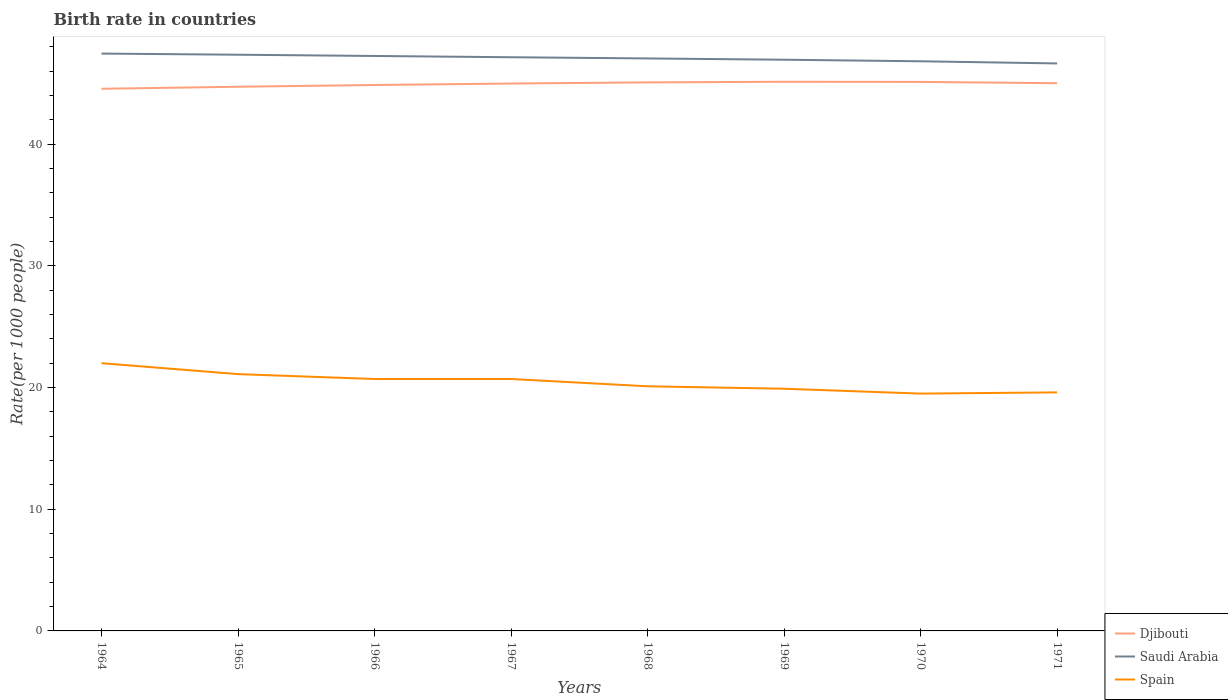How many different coloured lines are there?
Your response must be concise. 3. Does the line corresponding to Djibouti intersect with the line corresponding to Saudi Arabia?
Provide a succinct answer. No. Across all years, what is the maximum birth rate in Saudi Arabia?
Offer a terse response. 46.63. In which year was the birth rate in Djibouti maximum?
Keep it short and to the point. 1964. What is the total birth rate in Spain in the graph?
Ensure brevity in your answer.  1.2. What is the difference between the highest and the second highest birth rate in Saudi Arabia?
Provide a short and direct response. 0.81. What is the difference between the highest and the lowest birth rate in Djibouti?
Keep it short and to the point. 5. Is the birth rate in Djibouti strictly greater than the birth rate in Spain over the years?
Give a very brief answer. No. How many lines are there?
Your response must be concise. 3. How many years are there in the graph?
Offer a very short reply. 8. Are the values on the major ticks of Y-axis written in scientific E-notation?
Your answer should be very brief. No. Does the graph contain any zero values?
Give a very brief answer. No. Where does the legend appear in the graph?
Your answer should be very brief. Bottom right. How many legend labels are there?
Offer a terse response. 3. How are the legend labels stacked?
Provide a short and direct response. Vertical. What is the title of the graph?
Your answer should be compact. Birth rate in countries. What is the label or title of the Y-axis?
Your response must be concise. Rate(per 1000 people). What is the Rate(per 1000 people) in Djibouti in 1964?
Your answer should be compact. 44.55. What is the Rate(per 1000 people) of Saudi Arabia in 1964?
Your answer should be very brief. 47.44. What is the Rate(per 1000 people) of Spain in 1964?
Ensure brevity in your answer.  22. What is the Rate(per 1000 people) of Djibouti in 1965?
Your answer should be compact. 44.71. What is the Rate(per 1000 people) of Saudi Arabia in 1965?
Offer a very short reply. 47.34. What is the Rate(per 1000 people) of Spain in 1965?
Give a very brief answer. 21.1. What is the Rate(per 1000 people) of Djibouti in 1966?
Keep it short and to the point. 44.86. What is the Rate(per 1000 people) in Saudi Arabia in 1966?
Provide a succinct answer. 47.24. What is the Rate(per 1000 people) of Spain in 1966?
Offer a very short reply. 20.7. What is the Rate(per 1000 people) in Djibouti in 1967?
Give a very brief answer. 44.98. What is the Rate(per 1000 people) of Saudi Arabia in 1967?
Make the answer very short. 47.14. What is the Rate(per 1000 people) of Spain in 1967?
Your answer should be compact. 20.7. What is the Rate(per 1000 people) in Djibouti in 1968?
Your answer should be very brief. 45.07. What is the Rate(per 1000 people) in Saudi Arabia in 1968?
Your answer should be compact. 47.04. What is the Rate(per 1000 people) of Spain in 1968?
Offer a terse response. 20.1. What is the Rate(per 1000 people) in Djibouti in 1969?
Make the answer very short. 45.12. What is the Rate(per 1000 people) in Saudi Arabia in 1969?
Provide a succinct answer. 46.93. What is the Rate(per 1000 people) in Spain in 1969?
Your response must be concise. 19.9. What is the Rate(per 1000 people) of Djibouti in 1970?
Provide a short and direct response. 45.11. What is the Rate(per 1000 people) of Saudi Arabia in 1970?
Give a very brief answer. 46.81. What is the Rate(per 1000 people) in Djibouti in 1971?
Provide a succinct answer. 45. What is the Rate(per 1000 people) of Saudi Arabia in 1971?
Provide a succinct answer. 46.63. What is the Rate(per 1000 people) in Spain in 1971?
Offer a very short reply. 19.6. Across all years, what is the maximum Rate(per 1000 people) in Djibouti?
Provide a succinct answer. 45.12. Across all years, what is the maximum Rate(per 1000 people) of Saudi Arabia?
Give a very brief answer. 47.44. Across all years, what is the minimum Rate(per 1000 people) in Djibouti?
Provide a short and direct response. 44.55. Across all years, what is the minimum Rate(per 1000 people) of Saudi Arabia?
Ensure brevity in your answer.  46.63. What is the total Rate(per 1000 people) in Djibouti in the graph?
Ensure brevity in your answer.  359.4. What is the total Rate(per 1000 people) in Saudi Arabia in the graph?
Provide a succinct answer. 376.57. What is the total Rate(per 1000 people) of Spain in the graph?
Offer a terse response. 163.6. What is the difference between the Rate(per 1000 people) in Djibouti in 1964 and that in 1965?
Offer a terse response. -0.17. What is the difference between the Rate(per 1000 people) of Saudi Arabia in 1964 and that in 1965?
Offer a very short reply. 0.09. What is the difference between the Rate(per 1000 people) in Djibouti in 1964 and that in 1966?
Offer a very short reply. -0.31. What is the difference between the Rate(per 1000 people) of Saudi Arabia in 1964 and that in 1966?
Ensure brevity in your answer.  0.2. What is the difference between the Rate(per 1000 people) of Djibouti in 1964 and that in 1967?
Your response must be concise. -0.43. What is the difference between the Rate(per 1000 people) in Spain in 1964 and that in 1967?
Give a very brief answer. 1.3. What is the difference between the Rate(per 1000 people) of Djibouti in 1964 and that in 1968?
Offer a very short reply. -0.53. What is the difference between the Rate(per 1000 people) in Djibouti in 1964 and that in 1969?
Keep it short and to the point. -0.58. What is the difference between the Rate(per 1000 people) in Saudi Arabia in 1964 and that in 1969?
Give a very brief answer. 0.51. What is the difference between the Rate(per 1000 people) of Spain in 1964 and that in 1969?
Your answer should be very brief. 2.1. What is the difference between the Rate(per 1000 people) in Djibouti in 1964 and that in 1970?
Provide a short and direct response. -0.56. What is the difference between the Rate(per 1000 people) of Saudi Arabia in 1964 and that in 1970?
Make the answer very short. 0.63. What is the difference between the Rate(per 1000 people) of Djibouti in 1964 and that in 1971?
Your response must be concise. -0.46. What is the difference between the Rate(per 1000 people) in Saudi Arabia in 1964 and that in 1971?
Ensure brevity in your answer.  0.81. What is the difference between the Rate(per 1000 people) in Spain in 1964 and that in 1971?
Make the answer very short. 2.4. What is the difference between the Rate(per 1000 people) in Djibouti in 1965 and that in 1966?
Your response must be concise. -0.14. What is the difference between the Rate(per 1000 people) in Saudi Arabia in 1965 and that in 1966?
Ensure brevity in your answer.  0.1. What is the difference between the Rate(per 1000 people) of Spain in 1965 and that in 1966?
Keep it short and to the point. 0.4. What is the difference between the Rate(per 1000 people) in Djibouti in 1965 and that in 1967?
Provide a short and direct response. -0.27. What is the difference between the Rate(per 1000 people) of Saudi Arabia in 1965 and that in 1967?
Your response must be concise. 0.21. What is the difference between the Rate(per 1000 people) of Djibouti in 1965 and that in 1968?
Provide a short and direct response. -0.36. What is the difference between the Rate(per 1000 people) in Saudi Arabia in 1965 and that in 1968?
Your answer should be very brief. 0.31. What is the difference between the Rate(per 1000 people) in Djibouti in 1965 and that in 1969?
Your response must be concise. -0.41. What is the difference between the Rate(per 1000 people) of Saudi Arabia in 1965 and that in 1969?
Your answer should be compact. 0.41. What is the difference between the Rate(per 1000 people) of Djibouti in 1965 and that in 1970?
Give a very brief answer. -0.4. What is the difference between the Rate(per 1000 people) in Saudi Arabia in 1965 and that in 1970?
Make the answer very short. 0.54. What is the difference between the Rate(per 1000 people) in Djibouti in 1965 and that in 1971?
Your answer should be compact. -0.29. What is the difference between the Rate(per 1000 people) of Saudi Arabia in 1965 and that in 1971?
Offer a terse response. 0.72. What is the difference between the Rate(per 1000 people) in Djibouti in 1966 and that in 1967?
Give a very brief answer. -0.12. What is the difference between the Rate(per 1000 people) in Saudi Arabia in 1966 and that in 1967?
Make the answer very short. 0.1. What is the difference between the Rate(per 1000 people) in Spain in 1966 and that in 1967?
Your answer should be very brief. 0. What is the difference between the Rate(per 1000 people) of Djibouti in 1966 and that in 1968?
Give a very brief answer. -0.21. What is the difference between the Rate(per 1000 people) in Saudi Arabia in 1966 and that in 1968?
Offer a terse response. 0.2. What is the difference between the Rate(per 1000 people) of Djibouti in 1966 and that in 1969?
Your response must be concise. -0.27. What is the difference between the Rate(per 1000 people) of Saudi Arabia in 1966 and that in 1969?
Keep it short and to the point. 0.31. What is the difference between the Rate(per 1000 people) of Spain in 1966 and that in 1969?
Ensure brevity in your answer.  0.8. What is the difference between the Rate(per 1000 people) in Djibouti in 1966 and that in 1970?
Ensure brevity in your answer.  -0.25. What is the difference between the Rate(per 1000 people) of Saudi Arabia in 1966 and that in 1970?
Your response must be concise. 0.44. What is the difference between the Rate(per 1000 people) of Djibouti in 1966 and that in 1971?
Give a very brief answer. -0.15. What is the difference between the Rate(per 1000 people) in Saudi Arabia in 1966 and that in 1971?
Keep it short and to the point. 0.61. What is the difference between the Rate(per 1000 people) in Djibouti in 1967 and that in 1968?
Offer a terse response. -0.09. What is the difference between the Rate(per 1000 people) in Saudi Arabia in 1967 and that in 1968?
Provide a succinct answer. 0.1. What is the difference between the Rate(per 1000 people) in Spain in 1967 and that in 1968?
Ensure brevity in your answer.  0.6. What is the difference between the Rate(per 1000 people) of Djibouti in 1967 and that in 1969?
Your answer should be very brief. -0.14. What is the difference between the Rate(per 1000 people) of Saudi Arabia in 1967 and that in 1969?
Make the answer very short. 0.2. What is the difference between the Rate(per 1000 people) in Spain in 1967 and that in 1969?
Keep it short and to the point. 0.8. What is the difference between the Rate(per 1000 people) in Djibouti in 1967 and that in 1970?
Keep it short and to the point. -0.13. What is the difference between the Rate(per 1000 people) of Saudi Arabia in 1967 and that in 1970?
Your response must be concise. 0.33. What is the difference between the Rate(per 1000 people) in Spain in 1967 and that in 1970?
Your answer should be very brief. 1.2. What is the difference between the Rate(per 1000 people) in Djibouti in 1967 and that in 1971?
Your answer should be compact. -0.03. What is the difference between the Rate(per 1000 people) in Saudi Arabia in 1967 and that in 1971?
Provide a succinct answer. 0.51. What is the difference between the Rate(per 1000 people) of Spain in 1967 and that in 1971?
Make the answer very short. 1.1. What is the difference between the Rate(per 1000 people) of Djibouti in 1968 and that in 1969?
Keep it short and to the point. -0.05. What is the difference between the Rate(per 1000 people) of Saudi Arabia in 1968 and that in 1969?
Your response must be concise. 0.1. What is the difference between the Rate(per 1000 people) of Djibouti in 1968 and that in 1970?
Provide a short and direct response. -0.04. What is the difference between the Rate(per 1000 people) of Saudi Arabia in 1968 and that in 1970?
Give a very brief answer. 0.23. What is the difference between the Rate(per 1000 people) of Djibouti in 1968 and that in 1971?
Provide a short and direct response. 0.07. What is the difference between the Rate(per 1000 people) of Saudi Arabia in 1968 and that in 1971?
Keep it short and to the point. 0.41. What is the difference between the Rate(per 1000 people) in Spain in 1968 and that in 1971?
Your answer should be very brief. 0.5. What is the difference between the Rate(per 1000 people) in Djibouti in 1969 and that in 1970?
Offer a very short reply. 0.01. What is the difference between the Rate(per 1000 people) of Saudi Arabia in 1969 and that in 1970?
Give a very brief answer. 0.13. What is the difference between the Rate(per 1000 people) of Spain in 1969 and that in 1970?
Ensure brevity in your answer.  0.4. What is the difference between the Rate(per 1000 people) in Djibouti in 1969 and that in 1971?
Provide a succinct answer. 0.12. What is the difference between the Rate(per 1000 people) of Saudi Arabia in 1969 and that in 1971?
Keep it short and to the point. 0.3. What is the difference between the Rate(per 1000 people) in Djibouti in 1970 and that in 1971?
Offer a very short reply. 0.11. What is the difference between the Rate(per 1000 people) in Saudi Arabia in 1970 and that in 1971?
Make the answer very short. 0.18. What is the difference between the Rate(per 1000 people) of Djibouti in 1964 and the Rate(per 1000 people) of Saudi Arabia in 1965?
Your answer should be very brief. -2.8. What is the difference between the Rate(per 1000 people) in Djibouti in 1964 and the Rate(per 1000 people) in Spain in 1965?
Your response must be concise. 23.45. What is the difference between the Rate(per 1000 people) in Saudi Arabia in 1964 and the Rate(per 1000 people) in Spain in 1965?
Keep it short and to the point. 26.34. What is the difference between the Rate(per 1000 people) of Djibouti in 1964 and the Rate(per 1000 people) of Saudi Arabia in 1966?
Keep it short and to the point. -2.7. What is the difference between the Rate(per 1000 people) in Djibouti in 1964 and the Rate(per 1000 people) in Spain in 1966?
Make the answer very short. 23.85. What is the difference between the Rate(per 1000 people) of Saudi Arabia in 1964 and the Rate(per 1000 people) of Spain in 1966?
Your answer should be compact. 26.74. What is the difference between the Rate(per 1000 people) of Djibouti in 1964 and the Rate(per 1000 people) of Saudi Arabia in 1967?
Offer a very short reply. -2.59. What is the difference between the Rate(per 1000 people) in Djibouti in 1964 and the Rate(per 1000 people) in Spain in 1967?
Keep it short and to the point. 23.85. What is the difference between the Rate(per 1000 people) of Saudi Arabia in 1964 and the Rate(per 1000 people) of Spain in 1967?
Give a very brief answer. 26.74. What is the difference between the Rate(per 1000 people) of Djibouti in 1964 and the Rate(per 1000 people) of Saudi Arabia in 1968?
Offer a terse response. -2.49. What is the difference between the Rate(per 1000 people) of Djibouti in 1964 and the Rate(per 1000 people) of Spain in 1968?
Your answer should be compact. 24.45. What is the difference between the Rate(per 1000 people) in Saudi Arabia in 1964 and the Rate(per 1000 people) in Spain in 1968?
Provide a succinct answer. 27.34. What is the difference between the Rate(per 1000 people) of Djibouti in 1964 and the Rate(per 1000 people) of Saudi Arabia in 1969?
Your answer should be compact. -2.39. What is the difference between the Rate(per 1000 people) of Djibouti in 1964 and the Rate(per 1000 people) of Spain in 1969?
Keep it short and to the point. 24.65. What is the difference between the Rate(per 1000 people) in Saudi Arabia in 1964 and the Rate(per 1000 people) in Spain in 1969?
Offer a very short reply. 27.54. What is the difference between the Rate(per 1000 people) in Djibouti in 1964 and the Rate(per 1000 people) in Saudi Arabia in 1970?
Your answer should be very brief. -2.26. What is the difference between the Rate(per 1000 people) of Djibouti in 1964 and the Rate(per 1000 people) of Spain in 1970?
Your response must be concise. 25.05. What is the difference between the Rate(per 1000 people) in Saudi Arabia in 1964 and the Rate(per 1000 people) in Spain in 1970?
Provide a short and direct response. 27.94. What is the difference between the Rate(per 1000 people) of Djibouti in 1964 and the Rate(per 1000 people) of Saudi Arabia in 1971?
Make the answer very short. -2.08. What is the difference between the Rate(per 1000 people) in Djibouti in 1964 and the Rate(per 1000 people) in Spain in 1971?
Provide a short and direct response. 24.95. What is the difference between the Rate(per 1000 people) of Saudi Arabia in 1964 and the Rate(per 1000 people) of Spain in 1971?
Your answer should be compact. 27.84. What is the difference between the Rate(per 1000 people) of Djibouti in 1965 and the Rate(per 1000 people) of Saudi Arabia in 1966?
Provide a short and direct response. -2.53. What is the difference between the Rate(per 1000 people) of Djibouti in 1965 and the Rate(per 1000 people) of Spain in 1966?
Your answer should be very brief. 24.01. What is the difference between the Rate(per 1000 people) in Saudi Arabia in 1965 and the Rate(per 1000 people) in Spain in 1966?
Keep it short and to the point. 26.64. What is the difference between the Rate(per 1000 people) of Djibouti in 1965 and the Rate(per 1000 people) of Saudi Arabia in 1967?
Provide a short and direct response. -2.43. What is the difference between the Rate(per 1000 people) of Djibouti in 1965 and the Rate(per 1000 people) of Spain in 1967?
Offer a very short reply. 24.01. What is the difference between the Rate(per 1000 people) of Saudi Arabia in 1965 and the Rate(per 1000 people) of Spain in 1967?
Your answer should be compact. 26.64. What is the difference between the Rate(per 1000 people) in Djibouti in 1965 and the Rate(per 1000 people) in Saudi Arabia in 1968?
Provide a succinct answer. -2.33. What is the difference between the Rate(per 1000 people) in Djibouti in 1965 and the Rate(per 1000 people) in Spain in 1968?
Give a very brief answer. 24.61. What is the difference between the Rate(per 1000 people) of Saudi Arabia in 1965 and the Rate(per 1000 people) of Spain in 1968?
Provide a short and direct response. 27.25. What is the difference between the Rate(per 1000 people) of Djibouti in 1965 and the Rate(per 1000 people) of Saudi Arabia in 1969?
Provide a succinct answer. -2.22. What is the difference between the Rate(per 1000 people) of Djibouti in 1965 and the Rate(per 1000 people) of Spain in 1969?
Provide a short and direct response. 24.81. What is the difference between the Rate(per 1000 people) of Saudi Arabia in 1965 and the Rate(per 1000 people) of Spain in 1969?
Ensure brevity in your answer.  27.45. What is the difference between the Rate(per 1000 people) of Djibouti in 1965 and the Rate(per 1000 people) of Saudi Arabia in 1970?
Ensure brevity in your answer.  -2.09. What is the difference between the Rate(per 1000 people) in Djibouti in 1965 and the Rate(per 1000 people) in Spain in 1970?
Your response must be concise. 25.21. What is the difference between the Rate(per 1000 people) in Saudi Arabia in 1965 and the Rate(per 1000 people) in Spain in 1970?
Make the answer very short. 27.84. What is the difference between the Rate(per 1000 people) in Djibouti in 1965 and the Rate(per 1000 people) in Saudi Arabia in 1971?
Offer a very short reply. -1.92. What is the difference between the Rate(per 1000 people) in Djibouti in 1965 and the Rate(per 1000 people) in Spain in 1971?
Your answer should be compact. 25.11. What is the difference between the Rate(per 1000 people) of Saudi Arabia in 1965 and the Rate(per 1000 people) of Spain in 1971?
Your answer should be very brief. 27.75. What is the difference between the Rate(per 1000 people) of Djibouti in 1966 and the Rate(per 1000 people) of Saudi Arabia in 1967?
Your answer should be very brief. -2.28. What is the difference between the Rate(per 1000 people) in Djibouti in 1966 and the Rate(per 1000 people) in Spain in 1967?
Your response must be concise. 24.16. What is the difference between the Rate(per 1000 people) of Saudi Arabia in 1966 and the Rate(per 1000 people) of Spain in 1967?
Your answer should be compact. 26.54. What is the difference between the Rate(per 1000 people) of Djibouti in 1966 and the Rate(per 1000 people) of Saudi Arabia in 1968?
Your answer should be compact. -2.18. What is the difference between the Rate(per 1000 people) of Djibouti in 1966 and the Rate(per 1000 people) of Spain in 1968?
Give a very brief answer. 24.76. What is the difference between the Rate(per 1000 people) in Saudi Arabia in 1966 and the Rate(per 1000 people) in Spain in 1968?
Ensure brevity in your answer.  27.14. What is the difference between the Rate(per 1000 people) in Djibouti in 1966 and the Rate(per 1000 people) in Saudi Arabia in 1969?
Make the answer very short. -2.08. What is the difference between the Rate(per 1000 people) of Djibouti in 1966 and the Rate(per 1000 people) of Spain in 1969?
Ensure brevity in your answer.  24.96. What is the difference between the Rate(per 1000 people) in Saudi Arabia in 1966 and the Rate(per 1000 people) in Spain in 1969?
Your response must be concise. 27.34. What is the difference between the Rate(per 1000 people) of Djibouti in 1966 and the Rate(per 1000 people) of Saudi Arabia in 1970?
Ensure brevity in your answer.  -1.95. What is the difference between the Rate(per 1000 people) of Djibouti in 1966 and the Rate(per 1000 people) of Spain in 1970?
Offer a terse response. 25.36. What is the difference between the Rate(per 1000 people) of Saudi Arabia in 1966 and the Rate(per 1000 people) of Spain in 1970?
Your response must be concise. 27.74. What is the difference between the Rate(per 1000 people) of Djibouti in 1966 and the Rate(per 1000 people) of Saudi Arabia in 1971?
Your answer should be compact. -1.77. What is the difference between the Rate(per 1000 people) of Djibouti in 1966 and the Rate(per 1000 people) of Spain in 1971?
Provide a succinct answer. 25.26. What is the difference between the Rate(per 1000 people) of Saudi Arabia in 1966 and the Rate(per 1000 people) of Spain in 1971?
Offer a terse response. 27.64. What is the difference between the Rate(per 1000 people) of Djibouti in 1967 and the Rate(per 1000 people) of Saudi Arabia in 1968?
Keep it short and to the point. -2.06. What is the difference between the Rate(per 1000 people) in Djibouti in 1967 and the Rate(per 1000 people) in Spain in 1968?
Provide a succinct answer. 24.88. What is the difference between the Rate(per 1000 people) of Saudi Arabia in 1967 and the Rate(per 1000 people) of Spain in 1968?
Give a very brief answer. 27.04. What is the difference between the Rate(per 1000 people) in Djibouti in 1967 and the Rate(per 1000 people) in Saudi Arabia in 1969?
Keep it short and to the point. -1.96. What is the difference between the Rate(per 1000 people) in Djibouti in 1967 and the Rate(per 1000 people) in Spain in 1969?
Provide a succinct answer. 25.08. What is the difference between the Rate(per 1000 people) of Saudi Arabia in 1967 and the Rate(per 1000 people) of Spain in 1969?
Provide a short and direct response. 27.24. What is the difference between the Rate(per 1000 people) of Djibouti in 1967 and the Rate(per 1000 people) of Saudi Arabia in 1970?
Your answer should be compact. -1.83. What is the difference between the Rate(per 1000 people) of Djibouti in 1967 and the Rate(per 1000 people) of Spain in 1970?
Provide a short and direct response. 25.48. What is the difference between the Rate(per 1000 people) of Saudi Arabia in 1967 and the Rate(per 1000 people) of Spain in 1970?
Provide a succinct answer. 27.64. What is the difference between the Rate(per 1000 people) of Djibouti in 1967 and the Rate(per 1000 people) of Saudi Arabia in 1971?
Ensure brevity in your answer.  -1.65. What is the difference between the Rate(per 1000 people) of Djibouti in 1967 and the Rate(per 1000 people) of Spain in 1971?
Your response must be concise. 25.38. What is the difference between the Rate(per 1000 people) of Saudi Arabia in 1967 and the Rate(per 1000 people) of Spain in 1971?
Provide a short and direct response. 27.54. What is the difference between the Rate(per 1000 people) of Djibouti in 1968 and the Rate(per 1000 people) of Saudi Arabia in 1969?
Make the answer very short. -1.86. What is the difference between the Rate(per 1000 people) of Djibouti in 1968 and the Rate(per 1000 people) of Spain in 1969?
Offer a terse response. 25.17. What is the difference between the Rate(per 1000 people) of Saudi Arabia in 1968 and the Rate(per 1000 people) of Spain in 1969?
Your answer should be very brief. 27.14. What is the difference between the Rate(per 1000 people) in Djibouti in 1968 and the Rate(per 1000 people) in Saudi Arabia in 1970?
Make the answer very short. -1.74. What is the difference between the Rate(per 1000 people) of Djibouti in 1968 and the Rate(per 1000 people) of Spain in 1970?
Ensure brevity in your answer.  25.57. What is the difference between the Rate(per 1000 people) in Saudi Arabia in 1968 and the Rate(per 1000 people) in Spain in 1970?
Offer a terse response. 27.54. What is the difference between the Rate(per 1000 people) in Djibouti in 1968 and the Rate(per 1000 people) in Saudi Arabia in 1971?
Your answer should be compact. -1.56. What is the difference between the Rate(per 1000 people) in Djibouti in 1968 and the Rate(per 1000 people) in Spain in 1971?
Give a very brief answer. 25.47. What is the difference between the Rate(per 1000 people) of Saudi Arabia in 1968 and the Rate(per 1000 people) of Spain in 1971?
Give a very brief answer. 27.44. What is the difference between the Rate(per 1000 people) in Djibouti in 1969 and the Rate(per 1000 people) in Saudi Arabia in 1970?
Offer a terse response. -1.68. What is the difference between the Rate(per 1000 people) of Djibouti in 1969 and the Rate(per 1000 people) of Spain in 1970?
Ensure brevity in your answer.  25.62. What is the difference between the Rate(per 1000 people) in Saudi Arabia in 1969 and the Rate(per 1000 people) in Spain in 1970?
Provide a succinct answer. 27.43. What is the difference between the Rate(per 1000 people) of Djibouti in 1969 and the Rate(per 1000 people) of Saudi Arabia in 1971?
Provide a succinct answer. -1.51. What is the difference between the Rate(per 1000 people) of Djibouti in 1969 and the Rate(per 1000 people) of Spain in 1971?
Ensure brevity in your answer.  25.52. What is the difference between the Rate(per 1000 people) in Saudi Arabia in 1969 and the Rate(per 1000 people) in Spain in 1971?
Offer a very short reply. 27.33. What is the difference between the Rate(per 1000 people) of Djibouti in 1970 and the Rate(per 1000 people) of Saudi Arabia in 1971?
Keep it short and to the point. -1.52. What is the difference between the Rate(per 1000 people) of Djibouti in 1970 and the Rate(per 1000 people) of Spain in 1971?
Make the answer very short. 25.51. What is the difference between the Rate(per 1000 people) of Saudi Arabia in 1970 and the Rate(per 1000 people) of Spain in 1971?
Provide a succinct answer. 27.21. What is the average Rate(per 1000 people) in Djibouti per year?
Offer a terse response. 44.93. What is the average Rate(per 1000 people) of Saudi Arabia per year?
Ensure brevity in your answer.  47.07. What is the average Rate(per 1000 people) of Spain per year?
Make the answer very short. 20.45. In the year 1964, what is the difference between the Rate(per 1000 people) in Djibouti and Rate(per 1000 people) in Saudi Arabia?
Offer a very short reply. -2.89. In the year 1964, what is the difference between the Rate(per 1000 people) in Djibouti and Rate(per 1000 people) in Spain?
Your answer should be very brief. 22.55. In the year 1964, what is the difference between the Rate(per 1000 people) in Saudi Arabia and Rate(per 1000 people) in Spain?
Keep it short and to the point. 25.44. In the year 1965, what is the difference between the Rate(per 1000 people) of Djibouti and Rate(per 1000 people) of Saudi Arabia?
Your response must be concise. -2.63. In the year 1965, what is the difference between the Rate(per 1000 people) of Djibouti and Rate(per 1000 people) of Spain?
Make the answer very short. 23.61. In the year 1965, what is the difference between the Rate(per 1000 people) of Saudi Arabia and Rate(per 1000 people) of Spain?
Offer a terse response. 26.25. In the year 1966, what is the difference between the Rate(per 1000 people) in Djibouti and Rate(per 1000 people) in Saudi Arabia?
Keep it short and to the point. -2.38. In the year 1966, what is the difference between the Rate(per 1000 people) of Djibouti and Rate(per 1000 people) of Spain?
Provide a succinct answer. 24.16. In the year 1966, what is the difference between the Rate(per 1000 people) in Saudi Arabia and Rate(per 1000 people) in Spain?
Offer a very short reply. 26.54. In the year 1967, what is the difference between the Rate(per 1000 people) of Djibouti and Rate(per 1000 people) of Saudi Arabia?
Provide a short and direct response. -2.16. In the year 1967, what is the difference between the Rate(per 1000 people) in Djibouti and Rate(per 1000 people) in Spain?
Your answer should be very brief. 24.28. In the year 1967, what is the difference between the Rate(per 1000 people) of Saudi Arabia and Rate(per 1000 people) of Spain?
Offer a terse response. 26.44. In the year 1968, what is the difference between the Rate(per 1000 people) of Djibouti and Rate(per 1000 people) of Saudi Arabia?
Give a very brief answer. -1.97. In the year 1968, what is the difference between the Rate(per 1000 people) in Djibouti and Rate(per 1000 people) in Spain?
Provide a succinct answer. 24.97. In the year 1968, what is the difference between the Rate(per 1000 people) of Saudi Arabia and Rate(per 1000 people) of Spain?
Keep it short and to the point. 26.94. In the year 1969, what is the difference between the Rate(per 1000 people) in Djibouti and Rate(per 1000 people) in Saudi Arabia?
Provide a short and direct response. -1.81. In the year 1969, what is the difference between the Rate(per 1000 people) of Djibouti and Rate(per 1000 people) of Spain?
Ensure brevity in your answer.  25.22. In the year 1969, what is the difference between the Rate(per 1000 people) in Saudi Arabia and Rate(per 1000 people) in Spain?
Provide a succinct answer. 27.03. In the year 1970, what is the difference between the Rate(per 1000 people) of Djibouti and Rate(per 1000 people) of Saudi Arabia?
Offer a very short reply. -1.7. In the year 1970, what is the difference between the Rate(per 1000 people) in Djibouti and Rate(per 1000 people) in Spain?
Your response must be concise. 25.61. In the year 1970, what is the difference between the Rate(per 1000 people) of Saudi Arabia and Rate(per 1000 people) of Spain?
Keep it short and to the point. 27.31. In the year 1971, what is the difference between the Rate(per 1000 people) in Djibouti and Rate(per 1000 people) in Saudi Arabia?
Your answer should be compact. -1.62. In the year 1971, what is the difference between the Rate(per 1000 people) in Djibouti and Rate(per 1000 people) in Spain?
Ensure brevity in your answer.  25.4. In the year 1971, what is the difference between the Rate(per 1000 people) of Saudi Arabia and Rate(per 1000 people) of Spain?
Ensure brevity in your answer.  27.03. What is the ratio of the Rate(per 1000 people) in Djibouti in 1964 to that in 1965?
Your answer should be compact. 1. What is the ratio of the Rate(per 1000 people) in Saudi Arabia in 1964 to that in 1965?
Make the answer very short. 1. What is the ratio of the Rate(per 1000 people) in Spain in 1964 to that in 1965?
Provide a succinct answer. 1.04. What is the ratio of the Rate(per 1000 people) in Djibouti in 1964 to that in 1966?
Offer a very short reply. 0.99. What is the ratio of the Rate(per 1000 people) in Spain in 1964 to that in 1966?
Your answer should be very brief. 1.06. What is the ratio of the Rate(per 1000 people) in Saudi Arabia in 1964 to that in 1967?
Keep it short and to the point. 1.01. What is the ratio of the Rate(per 1000 people) of Spain in 1964 to that in 1967?
Give a very brief answer. 1.06. What is the ratio of the Rate(per 1000 people) in Djibouti in 1964 to that in 1968?
Ensure brevity in your answer.  0.99. What is the ratio of the Rate(per 1000 people) of Saudi Arabia in 1964 to that in 1968?
Your response must be concise. 1.01. What is the ratio of the Rate(per 1000 people) of Spain in 1964 to that in 1968?
Your response must be concise. 1.09. What is the ratio of the Rate(per 1000 people) of Djibouti in 1964 to that in 1969?
Provide a short and direct response. 0.99. What is the ratio of the Rate(per 1000 people) in Saudi Arabia in 1964 to that in 1969?
Provide a succinct answer. 1.01. What is the ratio of the Rate(per 1000 people) in Spain in 1964 to that in 1969?
Keep it short and to the point. 1.11. What is the ratio of the Rate(per 1000 people) of Djibouti in 1964 to that in 1970?
Your answer should be compact. 0.99. What is the ratio of the Rate(per 1000 people) in Saudi Arabia in 1964 to that in 1970?
Offer a terse response. 1.01. What is the ratio of the Rate(per 1000 people) of Spain in 1964 to that in 1970?
Make the answer very short. 1.13. What is the ratio of the Rate(per 1000 people) of Djibouti in 1964 to that in 1971?
Your answer should be very brief. 0.99. What is the ratio of the Rate(per 1000 people) of Saudi Arabia in 1964 to that in 1971?
Provide a short and direct response. 1.02. What is the ratio of the Rate(per 1000 people) of Spain in 1964 to that in 1971?
Give a very brief answer. 1.12. What is the ratio of the Rate(per 1000 people) in Spain in 1965 to that in 1966?
Provide a short and direct response. 1.02. What is the ratio of the Rate(per 1000 people) of Djibouti in 1965 to that in 1967?
Your answer should be very brief. 0.99. What is the ratio of the Rate(per 1000 people) of Spain in 1965 to that in 1967?
Give a very brief answer. 1.02. What is the ratio of the Rate(per 1000 people) in Saudi Arabia in 1965 to that in 1968?
Offer a terse response. 1.01. What is the ratio of the Rate(per 1000 people) of Spain in 1965 to that in 1968?
Offer a terse response. 1.05. What is the ratio of the Rate(per 1000 people) in Djibouti in 1965 to that in 1969?
Offer a terse response. 0.99. What is the ratio of the Rate(per 1000 people) in Saudi Arabia in 1965 to that in 1969?
Offer a very short reply. 1.01. What is the ratio of the Rate(per 1000 people) in Spain in 1965 to that in 1969?
Provide a succinct answer. 1.06. What is the ratio of the Rate(per 1000 people) of Saudi Arabia in 1965 to that in 1970?
Provide a succinct answer. 1.01. What is the ratio of the Rate(per 1000 people) in Spain in 1965 to that in 1970?
Your answer should be very brief. 1.08. What is the ratio of the Rate(per 1000 people) of Djibouti in 1965 to that in 1971?
Keep it short and to the point. 0.99. What is the ratio of the Rate(per 1000 people) of Saudi Arabia in 1965 to that in 1971?
Provide a short and direct response. 1.02. What is the ratio of the Rate(per 1000 people) in Spain in 1965 to that in 1971?
Your answer should be very brief. 1.08. What is the ratio of the Rate(per 1000 people) in Saudi Arabia in 1966 to that in 1967?
Keep it short and to the point. 1. What is the ratio of the Rate(per 1000 people) in Spain in 1966 to that in 1967?
Your answer should be very brief. 1. What is the ratio of the Rate(per 1000 people) of Djibouti in 1966 to that in 1968?
Make the answer very short. 1. What is the ratio of the Rate(per 1000 people) in Saudi Arabia in 1966 to that in 1968?
Your response must be concise. 1. What is the ratio of the Rate(per 1000 people) in Spain in 1966 to that in 1968?
Offer a very short reply. 1.03. What is the ratio of the Rate(per 1000 people) of Saudi Arabia in 1966 to that in 1969?
Keep it short and to the point. 1.01. What is the ratio of the Rate(per 1000 people) in Spain in 1966 to that in 1969?
Offer a terse response. 1.04. What is the ratio of the Rate(per 1000 people) in Saudi Arabia in 1966 to that in 1970?
Keep it short and to the point. 1.01. What is the ratio of the Rate(per 1000 people) in Spain in 1966 to that in 1970?
Your response must be concise. 1.06. What is the ratio of the Rate(per 1000 people) in Djibouti in 1966 to that in 1971?
Your answer should be very brief. 1. What is the ratio of the Rate(per 1000 people) in Saudi Arabia in 1966 to that in 1971?
Offer a terse response. 1.01. What is the ratio of the Rate(per 1000 people) of Spain in 1966 to that in 1971?
Your answer should be very brief. 1.06. What is the ratio of the Rate(per 1000 people) of Saudi Arabia in 1967 to that in 1968?
Provide a short and direct response. 1. What is the ratio of the Rate(per 1000 people) in Spain in 1967 to that in 1968?
Make the answer very short. 1.03. What is the ratio of the Rate(per 1000 people) of Saudi Arabia in 1967 to that in 1969?
Ensure brevity in your answer.  1. What is the ratio of the Rate(per 1000 people) of Spain in 1967 to that in 1969?
Ensure brevity in your answer.  1.04. What is the ratio of the Rate(per 1000 people) of Saudi Arabia in 1967 to that in 1970?
Your answer should be very brief. 1.01. What is the ratio of the Rate(per 1000 people) in Spain in 1967 to that in 1970?
Provide a succinct answer. 1.06. What is the ratio of the Rate(per 1000 people) in Saudi Arabia in 1967 to that in 1971?
Give a very brief answer. 1.01. What is the ratio of the Rate(per 1000 people) in Spain in 1967 to that in 1971?
Offer a terse response. 1.06. What is the ratio of the Rate(per 1000 people) of Djibouti in 1968 to that in 1970?
Provide a succinct answer. 1. What is the ratio of the Rate(per 1000 people) of Spain in 1968 to that in 1970?
Provide a short and direct response. 1.03. What is the ratio of the Rate(per 1000 people) in Saudi Arabia in 1968 to that in 1971?
Give a very brief answer. 1.01. What is the ratio of the Rate(per 1000 people) in Spain in 1968 to that in 1971?
Provide a succinct answer. 1.03. What is the ratio of the Rate(per 1000 people) of Djibouti in 1969 to that in 1970?
Make the answer very short. 1. What is the ratio of the Rate(per 1000 people) in Saudi Arabia in 1969 to that in 1970?
Ensure brevity in your answer.  1. What is the ratio of the Rate(per 1000 people) of Spain in 1969 to that in 1970?
Offer a very short reply. 1.02. What is the ratio of the Rate(per 1000 people) in Djibouti in 1969 to that in 1971?
Provide a succinct answer. 1. What is the ratio of the Rate(per 1000 people) in Spain in 1969 to that in 1971?
Your answer should be compact. 1.02. What is the ratio of the Rate(per 1000 people) of Spain in 1970 to that in 1971?
Offer a terse response. 0.99. What is the difference between the highest and the second highest Rate(per 1000 people) in Djibouti?
Keep it short and to the point. 0.01. What is the difference between the highest and the second highest Rate(per 1000 people) of Saudi Arabia?
Provide a succinct answer. 0.09. What is the difference between the highest and the second highest Rate(per 1000 people) in Spain?
Your answer should be very brief. 0.9. What is the difference between the highest and the lowest Rate(per 1000 people) in Djibouti?
Make the answer very short. 0.58. What is the difference between the highest and the lowest Rate(per 1000 people) in Saudi Arabia?
Offer a very short reply. 0.81. 